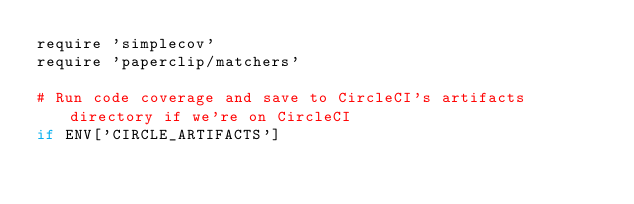<code> <loc_0><loc_0><loc_500><loc_500><_Ruby_>require 'simplecov'
require 'paperclip/matchers'

# Run code coverage and save to CircleCI's artifacts directory if we're on CircleCI
if ENV['CIRCLE_ARTIFACTS']</code> 